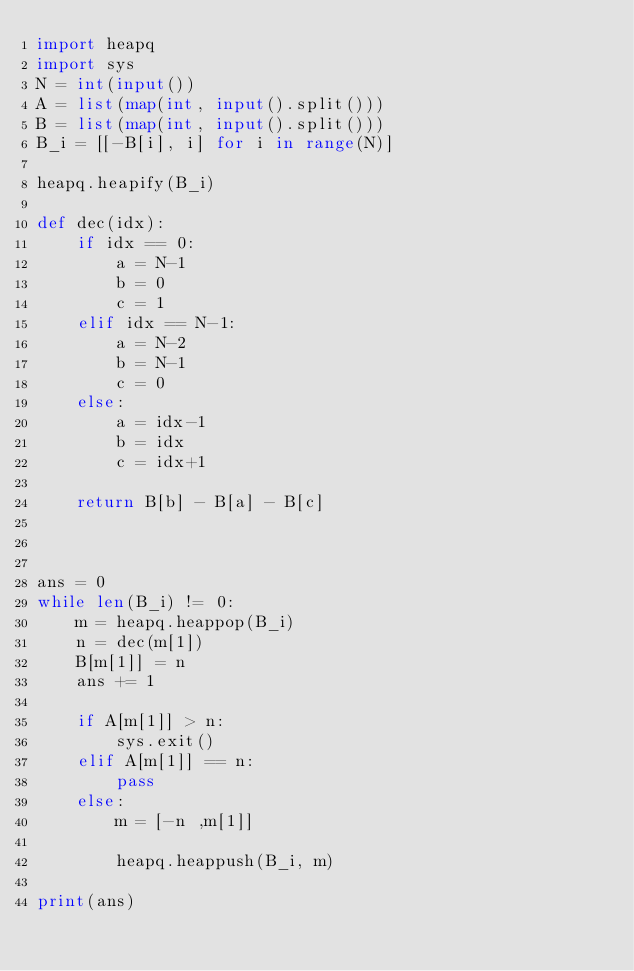Convert code to text. <code><loc_0><loc_0><loc_500><loc_500><_Python_>import heapq
import sys
N = int(input())
A = list(map(int, input().split()))
B = list(map(int, input().split()))
B_i = [[-B[i], i] for i in range(N)]

heapq.heapify(B_i)

def dec(idx):
    if idx == 0:
        a = N-1
        b = 0
        c = 1
    elif idx == N-1:
        a = N-2
        b = N-1
        c = 0
    else:
        a = idx-1
        b = idx
        c = idx+1

    return B[b] - B[a] - B[c]



ans = 0
while len(B_i) != 0:
    m = heapq.heappop(B_i)
    n = dec(m[1])
    B[m[1]] = n
    ans += 1

    if A[m[1]] > n:
        sys.exit()
    elif A[m[1]] == n:
        pass
    else:
        m = [-n ,m[1]]
        
        heapq.heappush(B_i, m)

print(ans)

</code> 